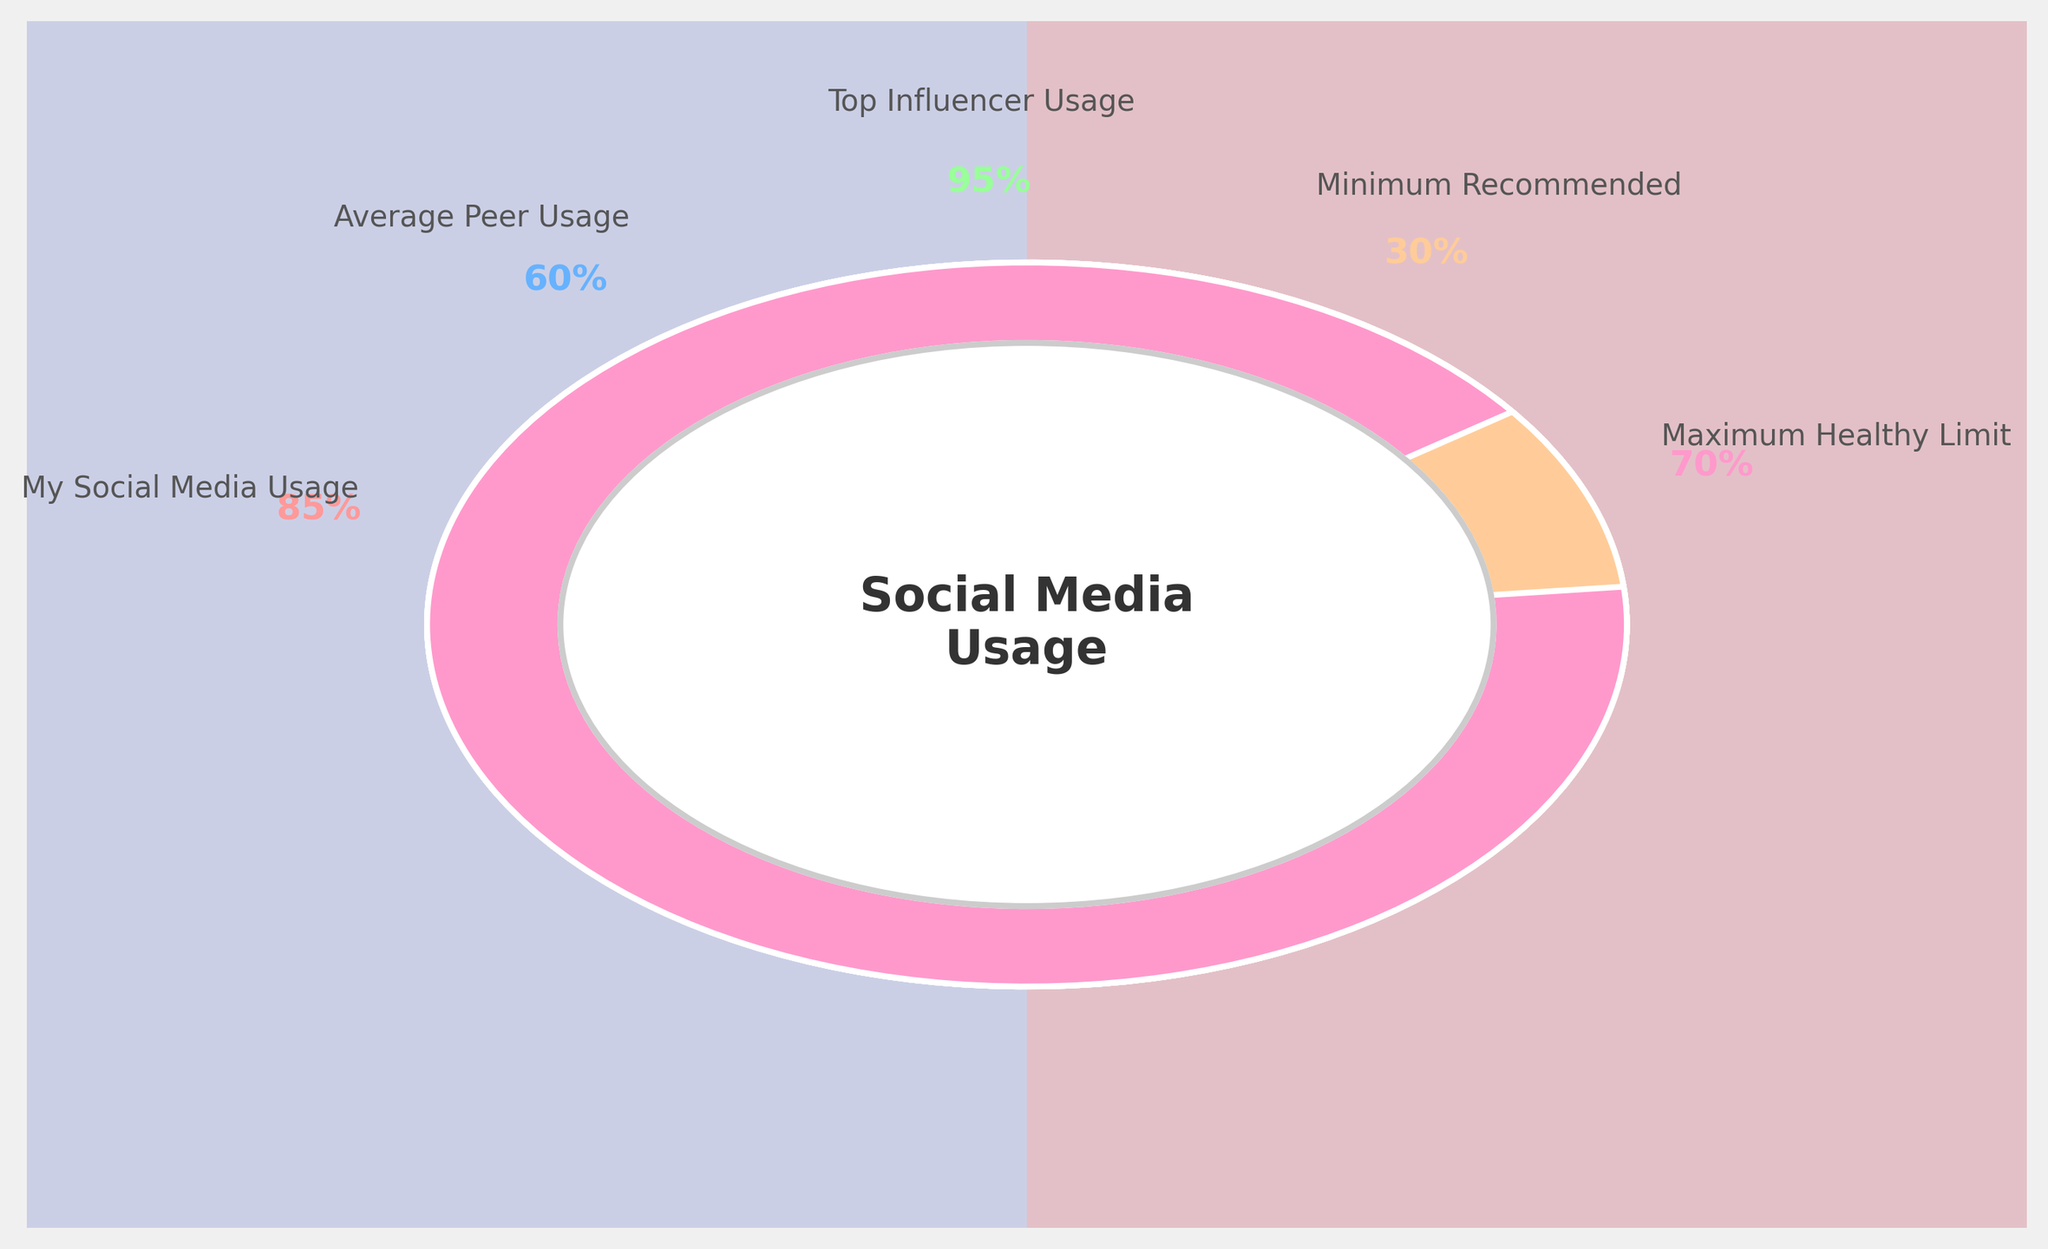What's the title displayed at the center of the gauge chart? The title is located in the center of the gauge chart, displayed in a larger and bold font.
Answer: Social Media Usage What percentage of time is spent on social media by an average peer? The average peer usage is represented as one of the colored segments in the chart, with 60% shown near the corresponding category label.
Answer: 60% Which category has the highest social media usage, and what percentage is it? By visually comparing the percentages next to each category, the "Top Influencer Usage" has the highest percentage, shown as 95%.
Answer: Top Influencer Usage, 95% Is your social media usage above or below the maximum healthy limit? Comparing "My Social Media Usage" (85%) to the "Maximum Healthy Limit" (70%), my usage is above the limit.
Answer: Above How much higher is your social media usage compared to the minimum recommended limit? Subtract the minimum recommended percentage (30%) from my usage (85%): 85% - 30% = 55%.
Answer: 55% Which category's usage is closest to the maximum healthy limit and what is that value? Comparing the percentages to the maximum healthy limit (70%), the closest value is "Average Peer Usage" at 60%.
Answer: Average Peer Usage, 60% How much lower is the average peer's usage compared to the top influencer's usage? Subtract the average peer usage (60%) from the top influencer usage (95%): 95% - 60% = 35%.
Answer: 35% Which categories have usage percentages listed above the minimum recommended limit? Any category with a percentage above 30%: "My Social Media Usage" (85%), "Average Peer Usage" (60%), "Top Influencer Usage" (95%).
Answer: My Social Media Usage, Average Peer Usage, Top Influencer Usage What is the difference between your social media usage and the maximum healthy limit? Subtract the maximum healthy limit (70%) from my usage (85%): 85% - 70% = 15%.
Answer: 15% If the sum of all percentages in the gauge chart is taken, what would it be? Summing all the listed percentages: 85% + 60% + 95% + 30% + 70% = 340%.
Answer: 340% 